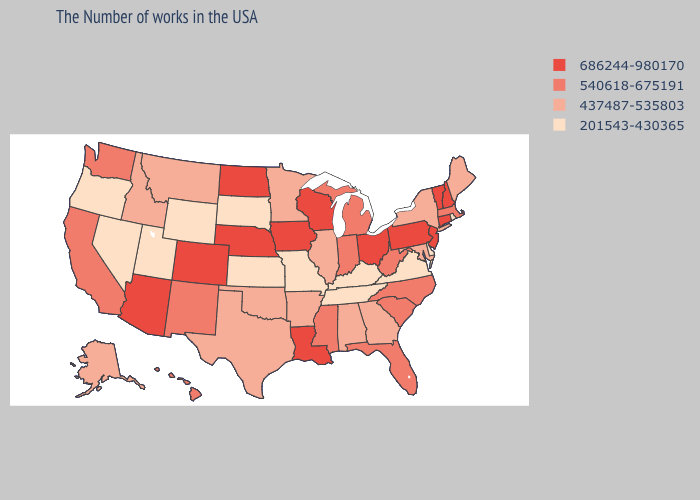What is the lowest value in states that border North Carolina?
Quick response, please. 201543-430365. Does Wyoming have the lowest value in the USA?
Quick response, please. Yes. Name the states that have a value in the range 437487-535803?
Short answer required. Maine, New York, Maryland, Georgia, Alabama, Illinois, Arkansas, Minnesota, Oklahoma, Texas, Montana, Idaho, Alaska. What is the value of Wisconsin?
Answer briefly. 686244-980170. Among the states that border Montana , does North Dakota have the highest value?
Answer briefly. Yes. What is the value of California?
Answer briefly. 540618-675191. What is the highest value in the Northeast ?
Give a very brief answer. 686244-980170. Which states have the lowest value in the MidWest?
Quick response, please. Missouri, Kansas, South Dakota. What is the highest value in the Northeast ?
Keep it brief. 686244-980170. Among the states that border Illinois , does Missouri have the lowest value?
Be succinct. Yes. Does Connecticut have the highest value in the Northeast?
Short answer required. Yes. What is the lowest value in the USA?
Be succinct. 201543-430365. Name the states that have a value in the range 540618-675191?
Be succinct. Massachusetts, North Carolina, South Carolina, West Virginia, Florida, Michigan, Indiana, Mississippi, New Mexico, California, Washington, Hawaii. What is the value of Maryland?
Quick response, please. 437487-535803. What is the value of Massachusetts?
Keep it brief. 540618-675191. 